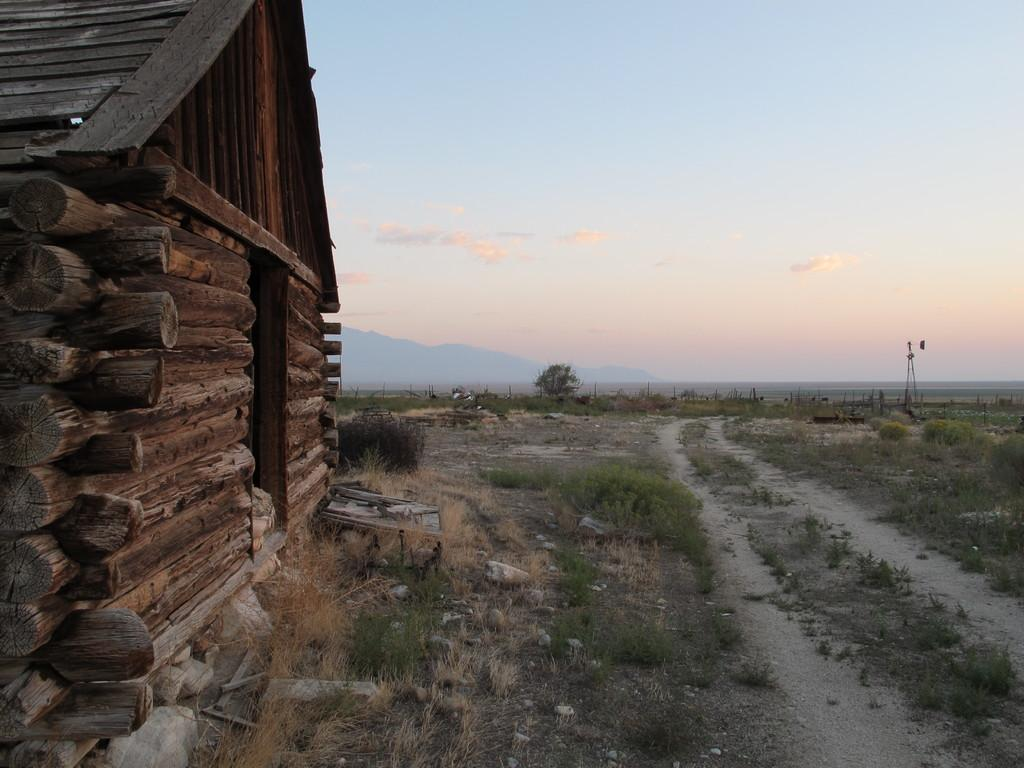What type of structure is located on the left side of the image? There is a wooden house on the left side of the image. What is the terrain like in the image? There is grass on the land in the image. What type of vegetation can be seen in the image? There are plants in the image. What can be seen in the background of the image? There is a tower, hills, and the sky visible in the background of the image. How many cows are grazing on the grass in the image? There are no cows present in the image; it features a wooden house, plants, a tower, hills, and the sky. What is the hope for the future of the wooden house in the image? The image does not provide any information about the future of the wooden house or any hopes related to it. 